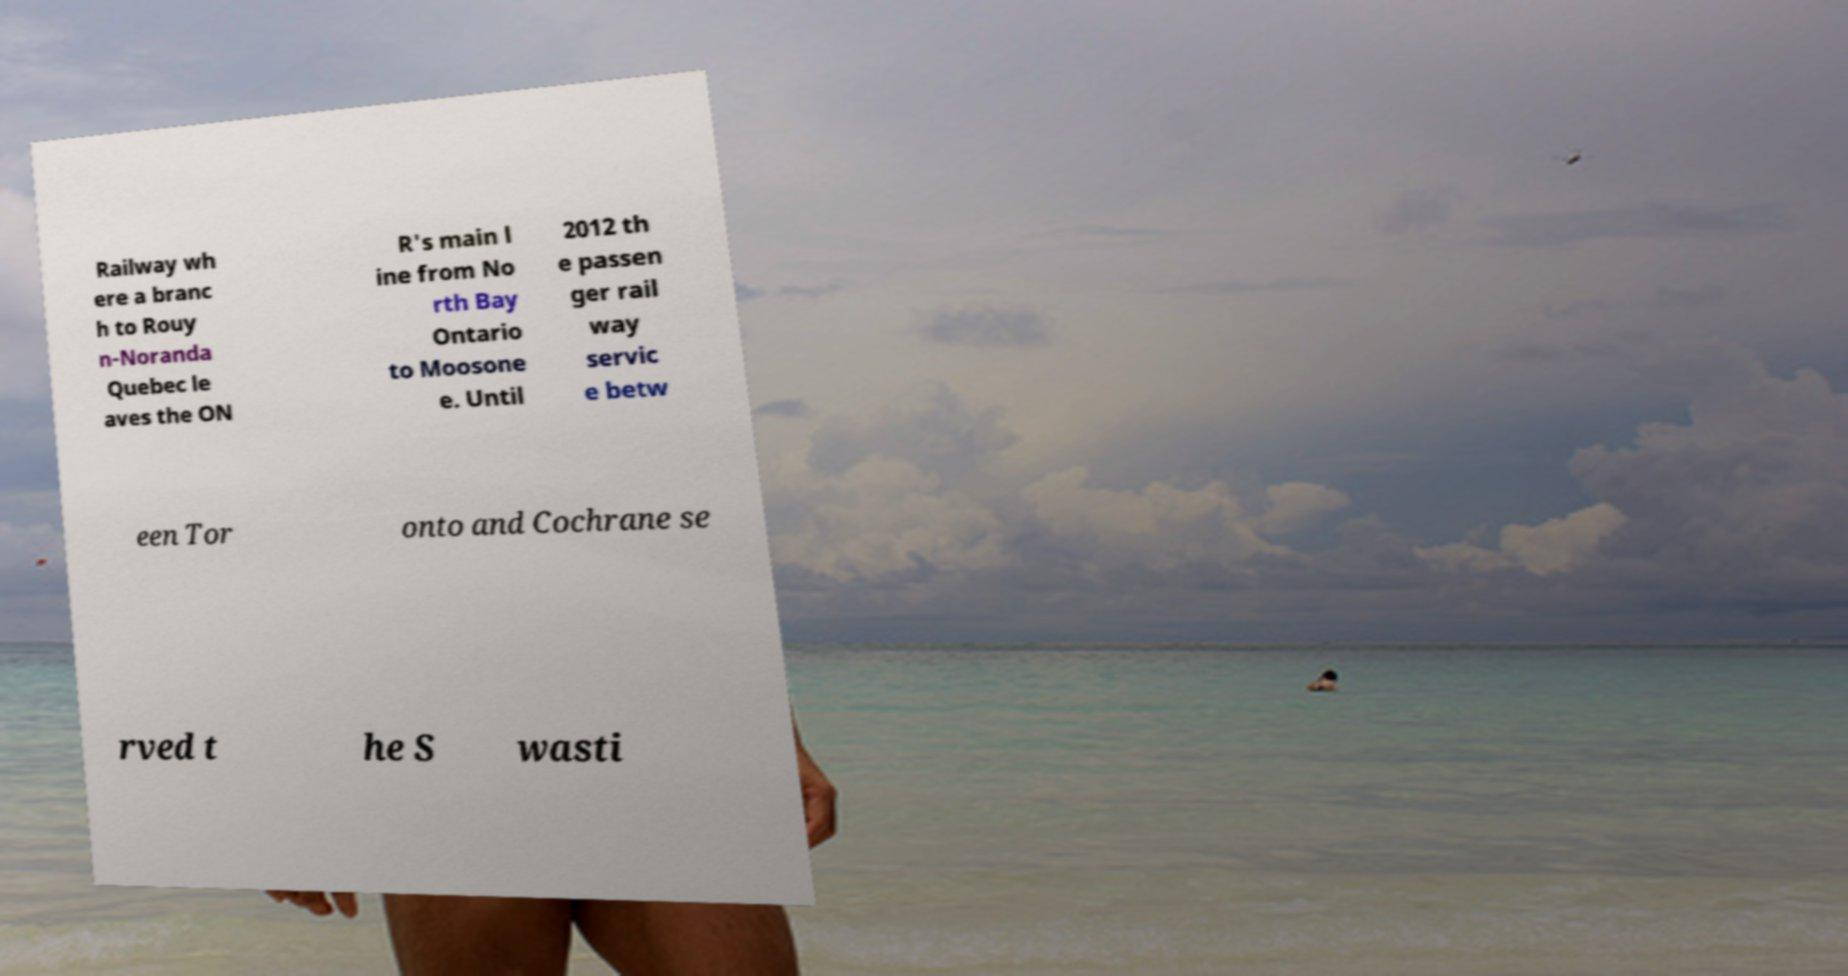I need the written content from this picture converted into text. Can you do that? Railway wh ere a branc h to Rouy n-Noranda Quebec le aves the ON R's main l ine from No rth Bay Ontario to Moosone e. Until 2012 th e passen ger rail way servic e betw een Tor onto and Cochrane se rved t he S wasti 